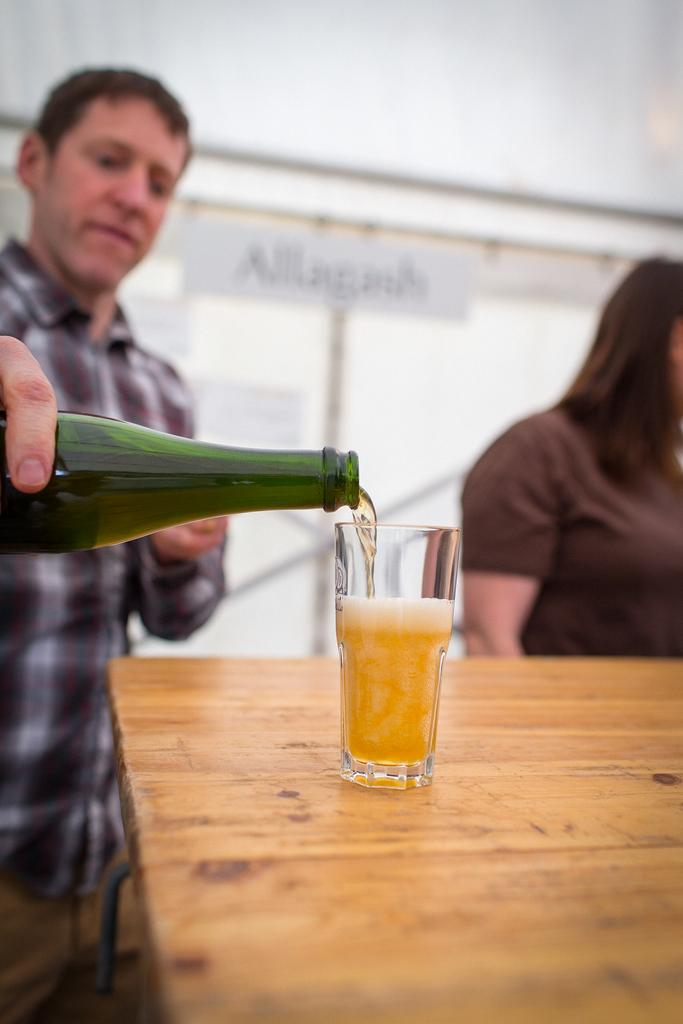How many people are in the image? There are two people in the image. What is the man holding in the image? The man is holding a bottle in the image. What is present on the table in the image? There is a table and a glass on the table in the image. What type of van can be seen in the background of the image? There is no van present in the image. Is there a sheet covering the table in the image? There is no sheet covering the table in the image; only a glass is present on the table. 